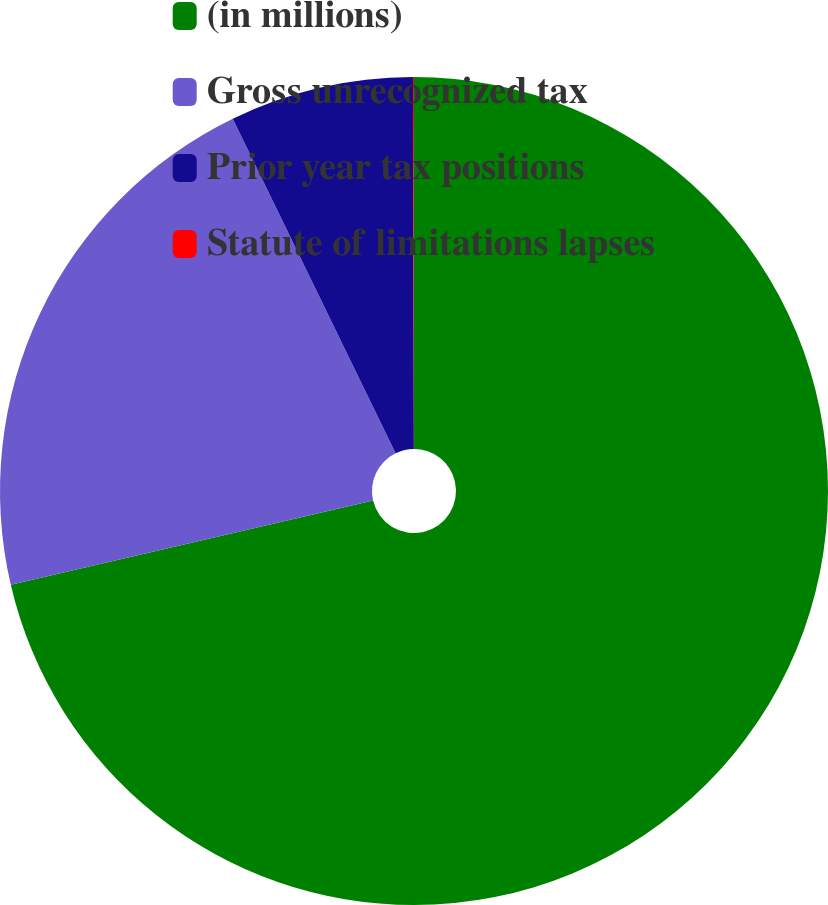Convert chart. <chart><loc_0><loc_0><loc_500><loc_500><pie_chart><fcel>(in millions)<fcel>Gross unrecognized tax<fcel>Prior year tax positions<fcel>Statute of limitations lapses<nl><fcel>71.36%<fcel>21.43%<fcel>7.17%<fcel>0.04%<nl></chart> 